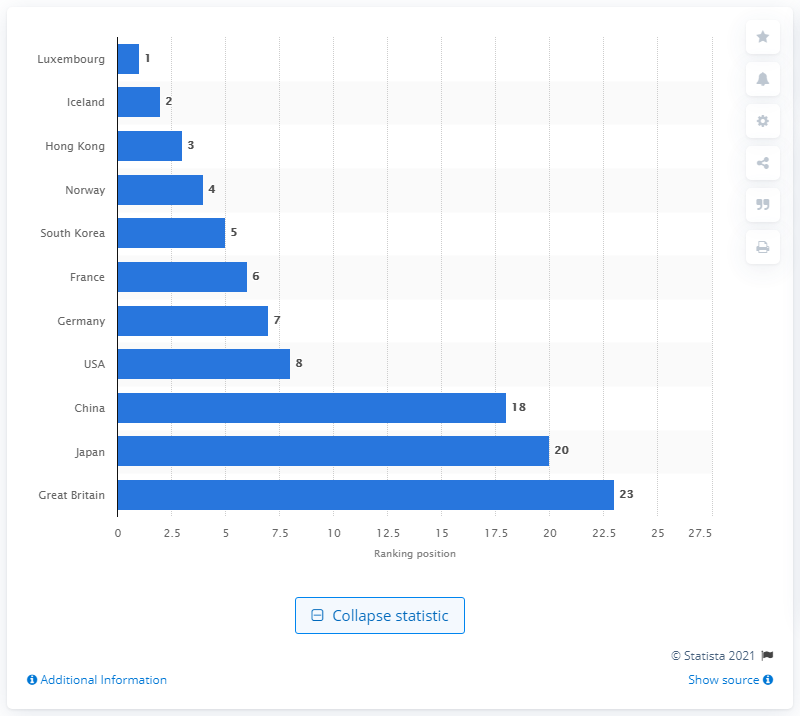Mention a couple of crucial points in this snapshot. Luxembourg is known for providing exceptional conditions that facilitate the efficient enforcement of contracts. 